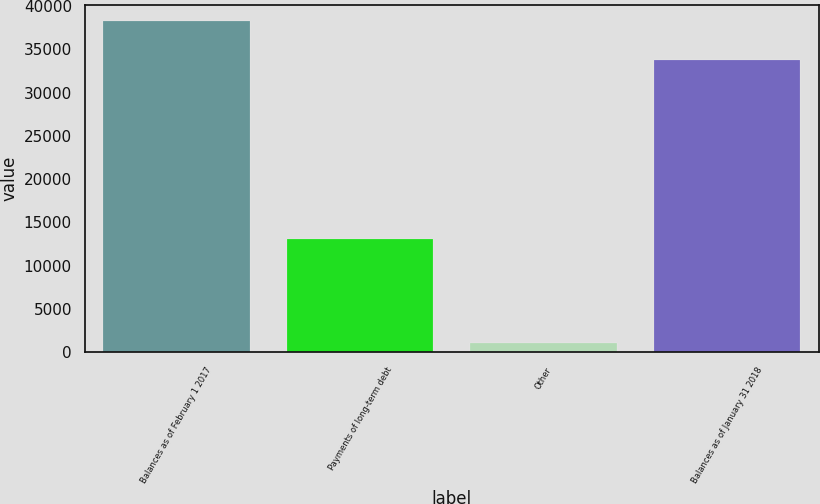<chart> <loc_0><loc_0><loc_500><loc_500><bar_chart><fcel>Balances as of February 1 2017<fcel>Payments of long-term debt<fcel>Other<fcel>Balances as of January 31 2018<nl><fcel>38271<fcel>13061<fcel>1097<fcel>33783<nl></chart> 